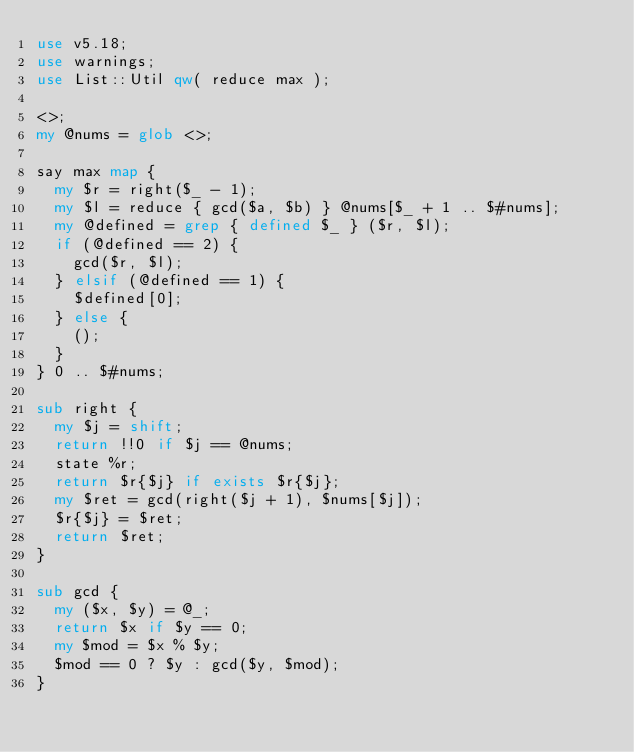<code> <loc_0><loc_0><loc_500><loc_500><_Perl_>use v5.18;
use warnings;
use List::Util qw( reduce max );
 
<>;
my @nums = glob <>;
 
say max map {
  my $r = right($_ - 1);
  my $l = reduce { gcd($a, $b) } @nums[$_ + 1 .. $#nums];
  my @defined = grep { defined $_ } ($r, $l);
  if (@defined == 2) {
    gcd($r, $l);
  } elsif (@defined == 1) {
    $defined[0];
  } else {
    ();
  }
} 0 .. $#nums;

sub right {
  my $j = shift;
  return !!0 if $j == @nums;
  state %r;
  return $r{$j} if exists $r{$j};
  my $ret = gcd(right($j + 1), $nums[$j]);
  $r{$j} = $ret;
  return $ret;
}
 
sub gcd {
  my ($x, $y) = @_;
  return $x if $y == 0;
  my $mod = $x % $y;
  $mod == 0 ? $y : gcd($y, $mod);
}
</code> 